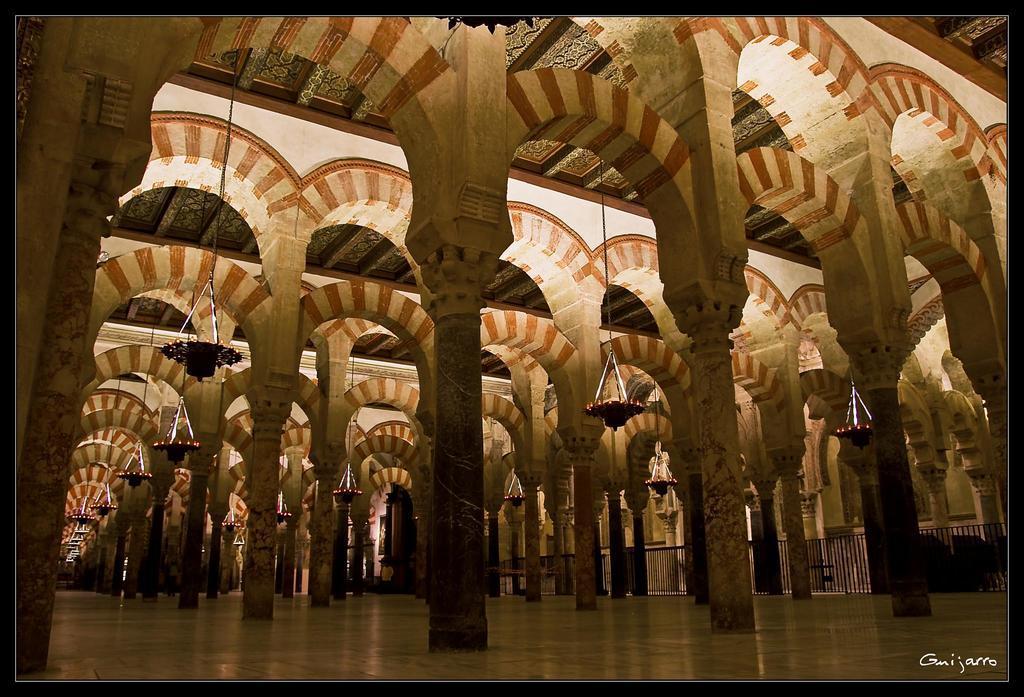In one or two sentences, can you explain what this image depicts? There is a floor at the bottom of this image and there are some pillars as we can see in the middle of this image. 